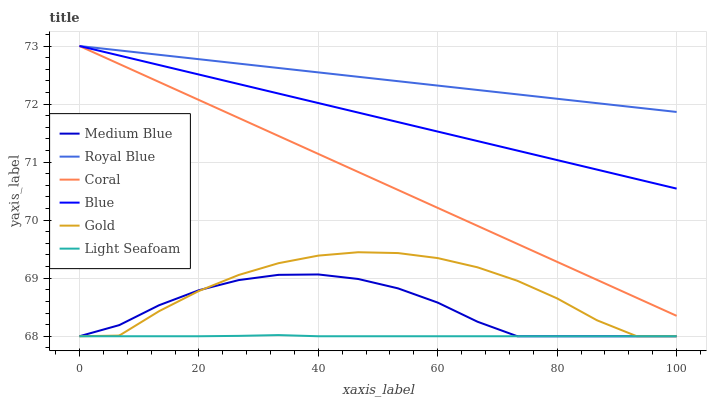Does Light Seafoam have the minimum area under the curve?
Answer yes or no. Yes. Does Royal Blue have the maximum area under the curve?
Answer yes or no. Yes. Does Gold have the minimum area under the curve?
Answer yes or no. No. Does Gold have the maximum area under the curve?
Answer yes or no. No. Is Blue the smoothest?
Answer yes or no. Yes. Is Gold the roughest?
Answer yes or no. Yes. Is Coral the smoothest?
Answer yes or no. No. Is Coral the roughest?
Answer yes or no. No. Does Coral have the lowest value?
Answer yes or no. No. Does Royal Blue have the highest value?
Answer yes or no. Yes. Does Gold have the highest value?
Answer yes or no. No. Is Gold less than Blue?
Answer yes or no. Yes. Is Coral greater than Gold?
Answer yes or no. Yes. Does Medium Blue intersect Gold?
Answer yes or no. Yes. Is Medium Blue less than Gold?
Answer yes or no. No. Is Medium Blue greater than Gold?
Answer yes or no. No. Does Gold intersect Blue?
Answer yes or no. No. 